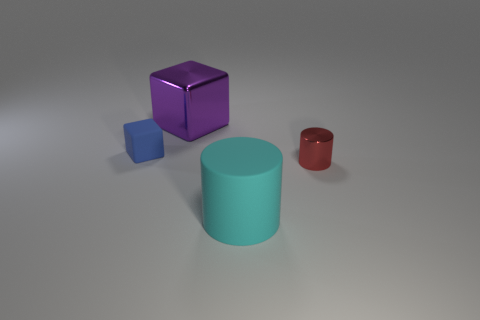What number of other things are the same shape as the small red shiny thing?
Offer a terse response. 1. What shape is the shiny object behind the thing that is on the left side of the metal thing that is behind the small red metallic cylinder?
Provide a succinct answer. Cube. What number of blocks are either big metallic objects or small rubber things?
Ensure brevity in your answer.  2. There is a shiny thing to the left of the big cyan matte cylinder; are there any big shiny cubes in front of it?
Your answer should be very brief. No. There is a red shiny object; does it have the same shape as the matte object in front of the tiny matte block?
Your answer should be very brief. Yes. What number of other objects are the same size as the red cylinder?
Ensure brevity in your answer.  1. What number of purple things are either large cylinders or big blocks?
Your answer should be compact. 1. How many small objects are both to the right of the purple metal block and left of the big metal cube?
Offer a terse response. 0. There is a large thing behind the small object in front of the tiny object that is on the left side of the big cylinder; what is it made of?
Keep it short and to the point. Metal. How many small objects have the same material as the cyan cylinder?
Keep it short and to the point. 1. 